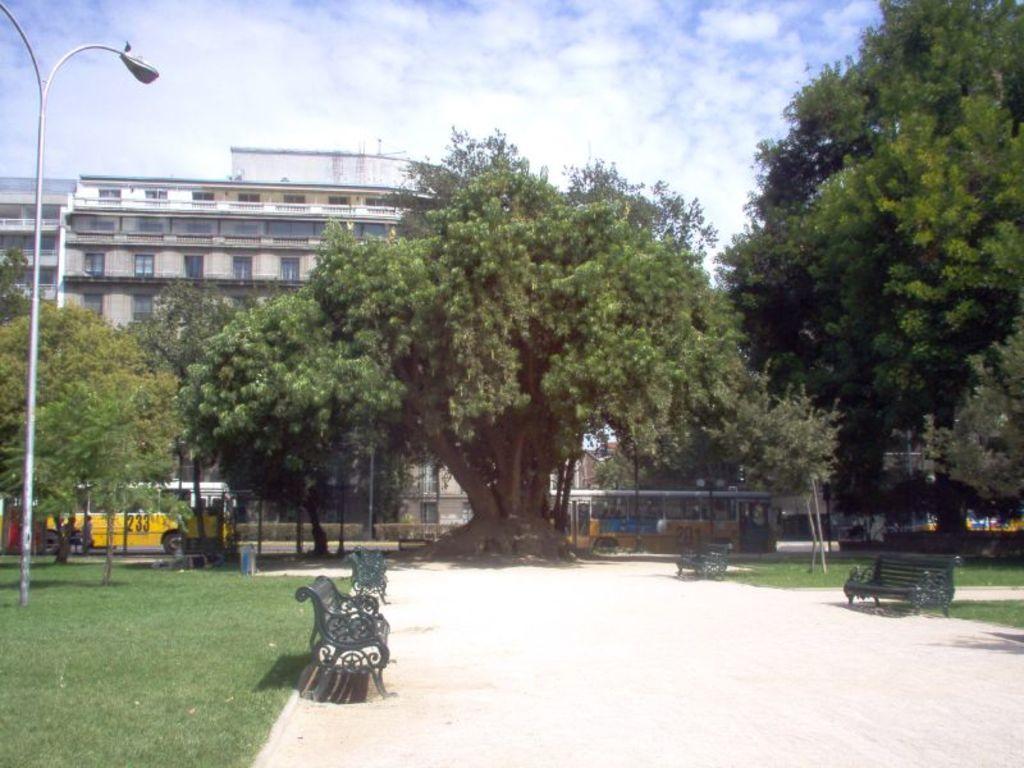Describe this image in one or two sentences. In the picture we can see a path besides the path we can see benches on the either sides and on the left hand side we can see a grass surface and a pole on it with light and in the background we can see trees and behind it we can see building with windows and near to the building we can see a bus is parked and behind the building we can see a sky. 